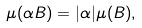Convert formula to latex. <formula><loc_0><loc_0><loc_500><loc_500>\mu ( \alpha B ) = | \alpha | \mu ( B ) ,</formula> 